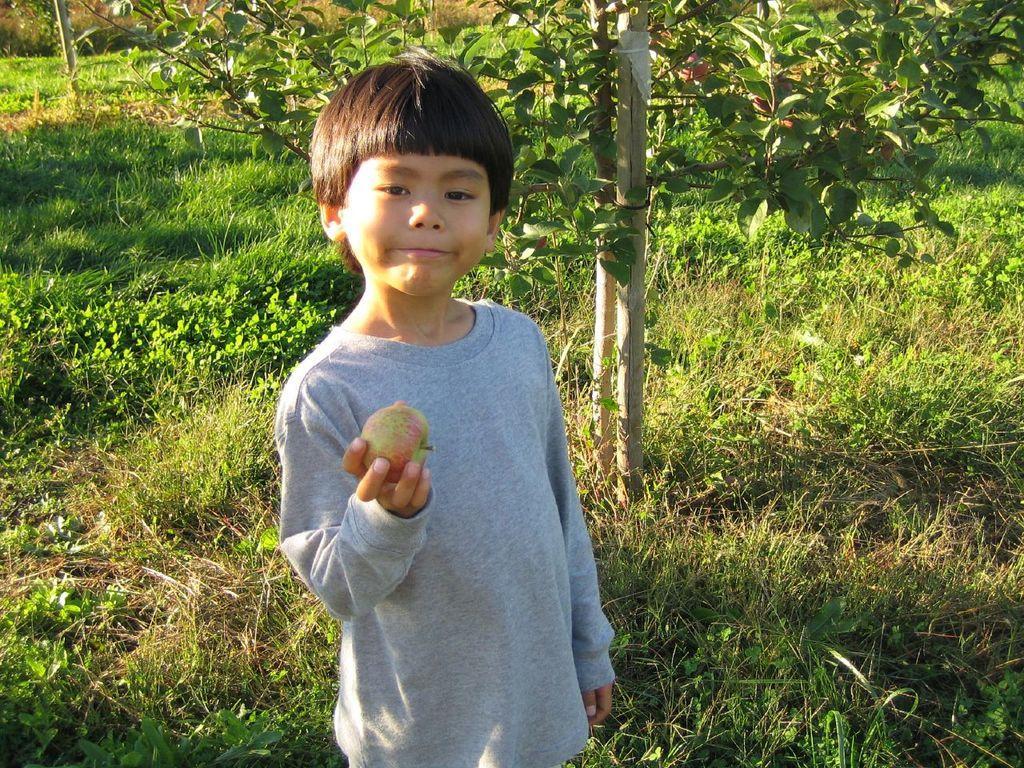Could you give a brief overview of what you see in this image? In this image we can see a child holding an apple. On the backside we can see some grass, plants and wooden poles. 